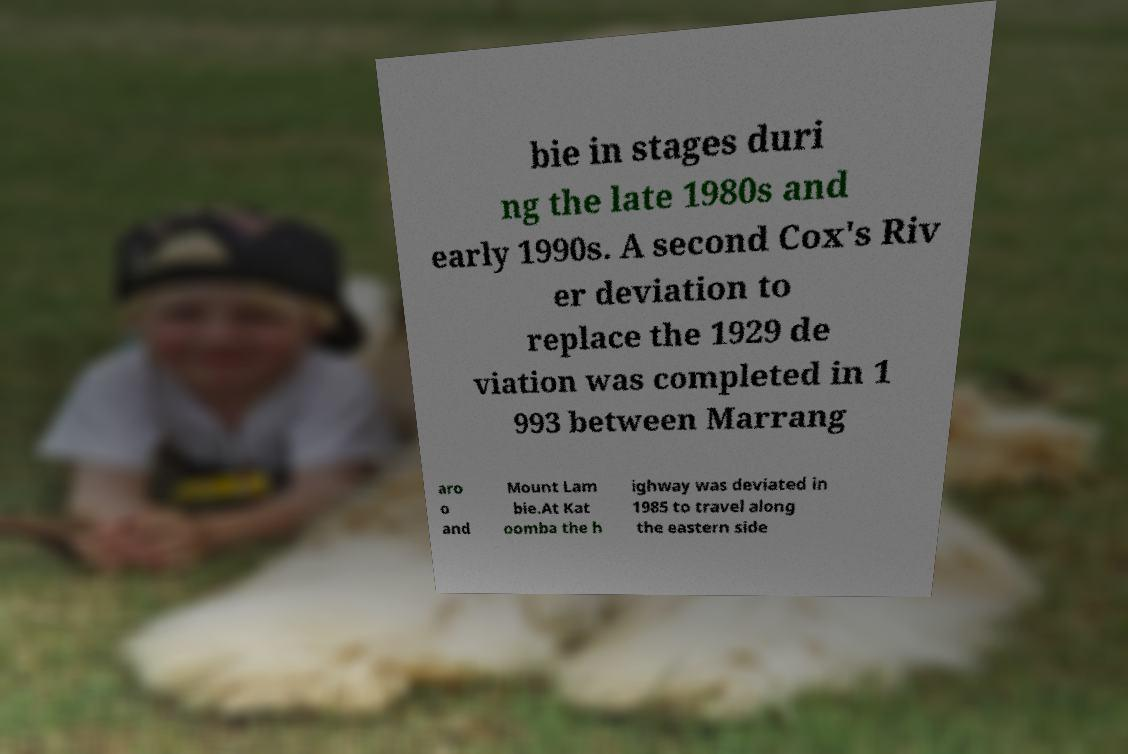Please identify and transcribe the text found in this image. bie in stages duri ng the late 1980s and early 1990s. A second Cox's Riv er deviation to replace the 1929 de viation was completed in 1 993 between Marrang aro o and Mount Lam bie.At Kat oomba the h ighway was deviated in 1985 to travel along the eastern side 